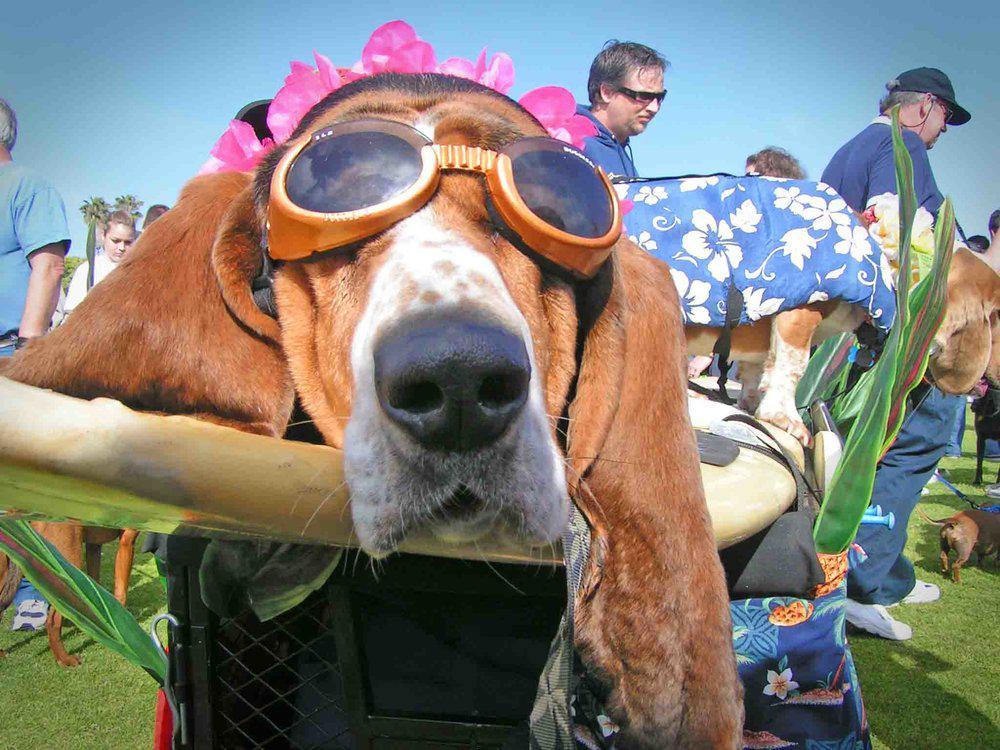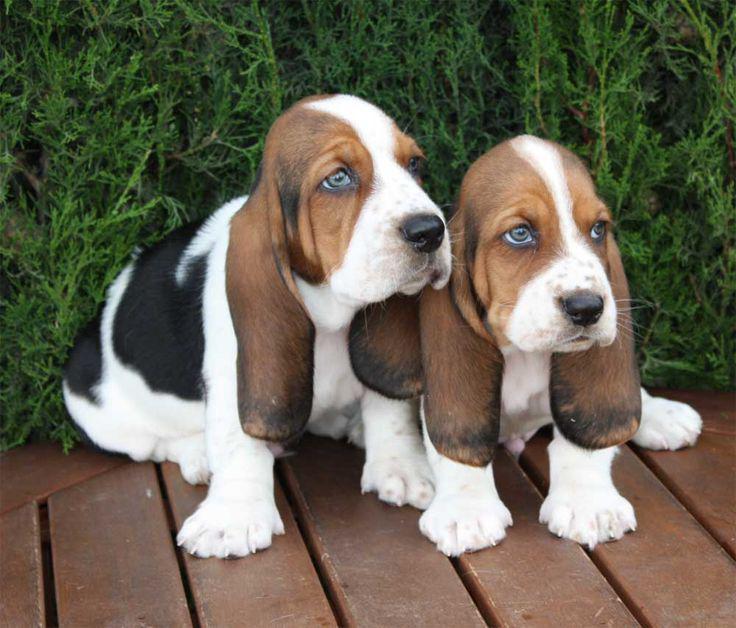The first image is the image on the left, the second image is the image on the right. Analyze the images presented: Is the assertion "There are two dogs in total." valid? Answer yes or no. No. The first image is the image on the left, the second image is the image on the right. Analyze the images presented: Is the assertion "An image shows at least one dog wearing a hat associated with an ingestible product that is also pictured." valid? Answer yes or no. No. 